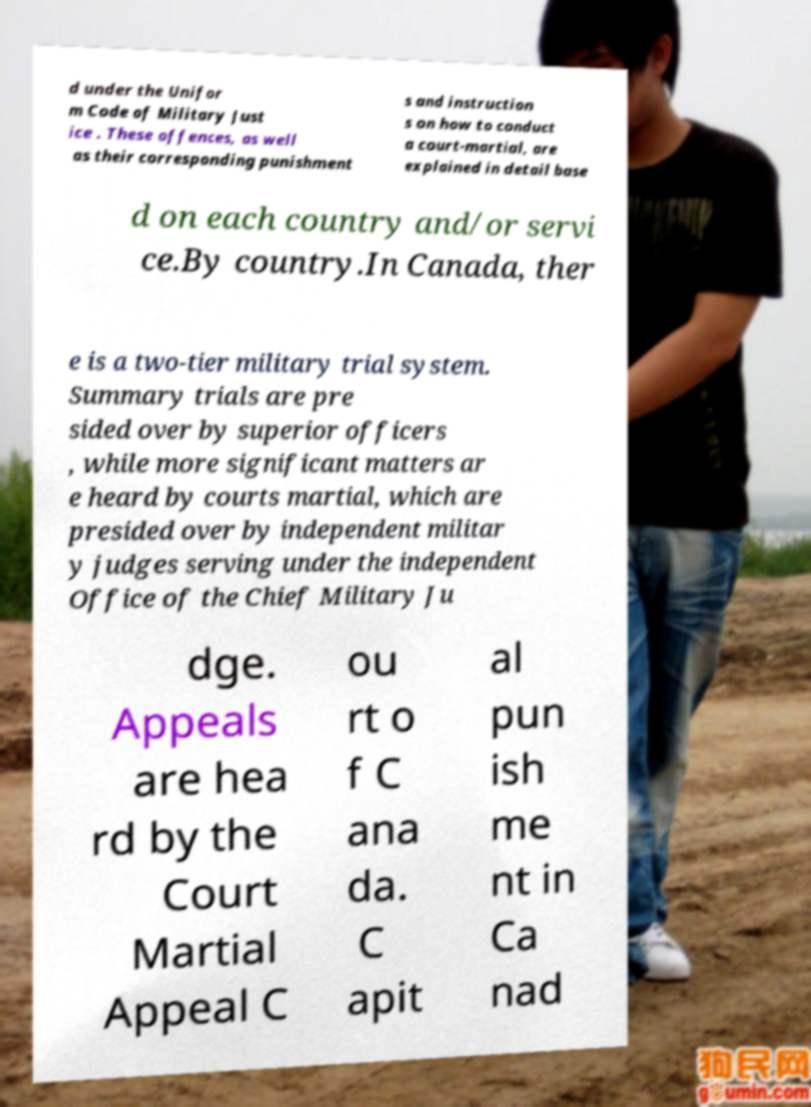There's text embedded in this image that I need extracted. Can you transcribe it verbatim? d under the Unifor m Code of Military Just ice . These offences, as well as their corresponding punishment s and instruction s on how to conduct a court-martial, are explained in detail base d on each country and/or servi ce.By country.In Canada, ther e is a two-tier military trial system. Summary trials are pre sided over by superior officers , while more significant matters ar e heard by courts martial, which are presided over by independent militar y judges serving under the independent Office of the Chief Military Ju dge. Appeals are hea rd by the Court Martial Appeal C ou rt o f C ana da. C apit al pun ish me nt in Ca nad 